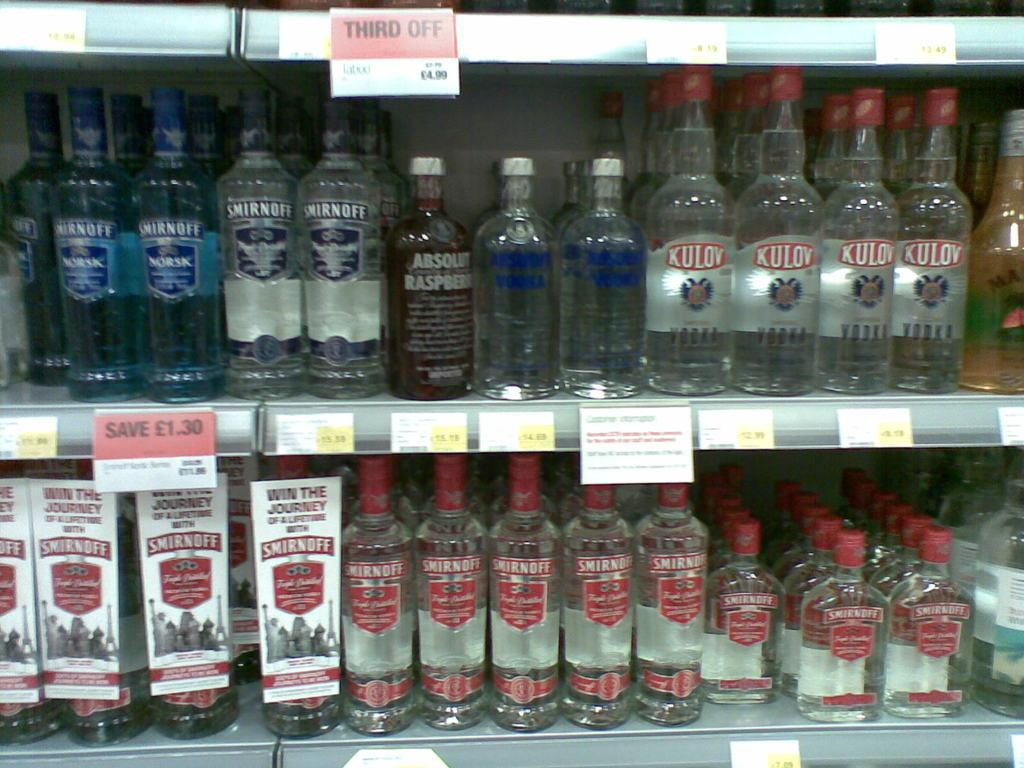<image>
Summarize the visual content of the image. A shelf filled with different bottles of vodka 